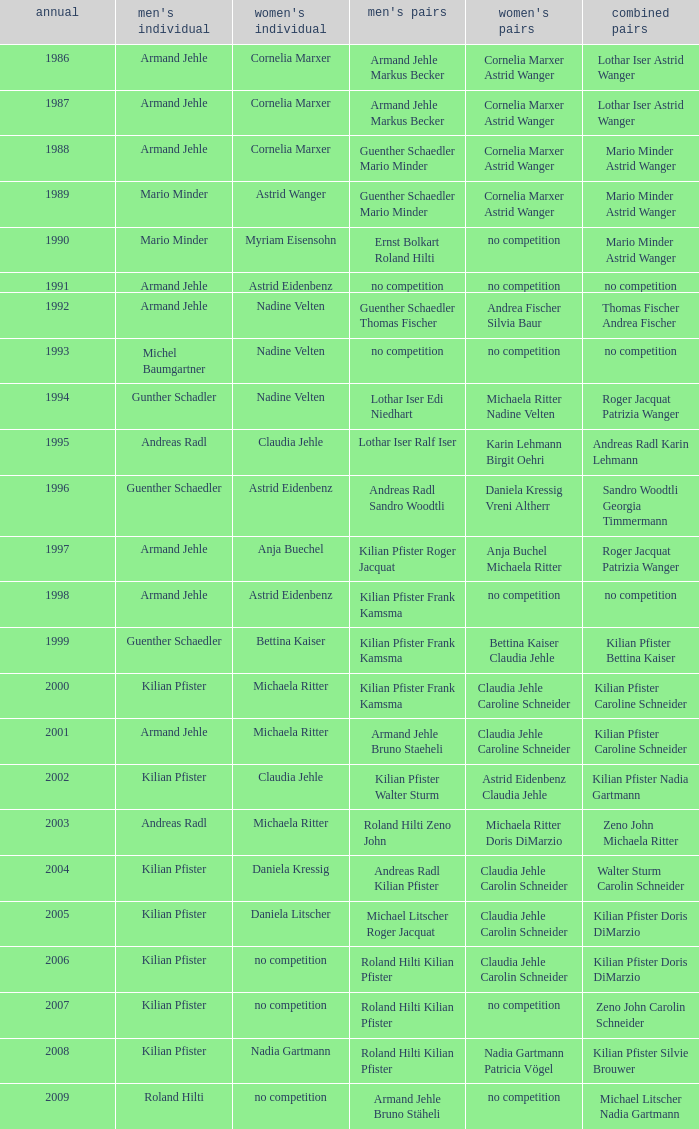What is the most current year where the women's doubles champions are astrid eidenbenz claudia jehle 2002.0. 